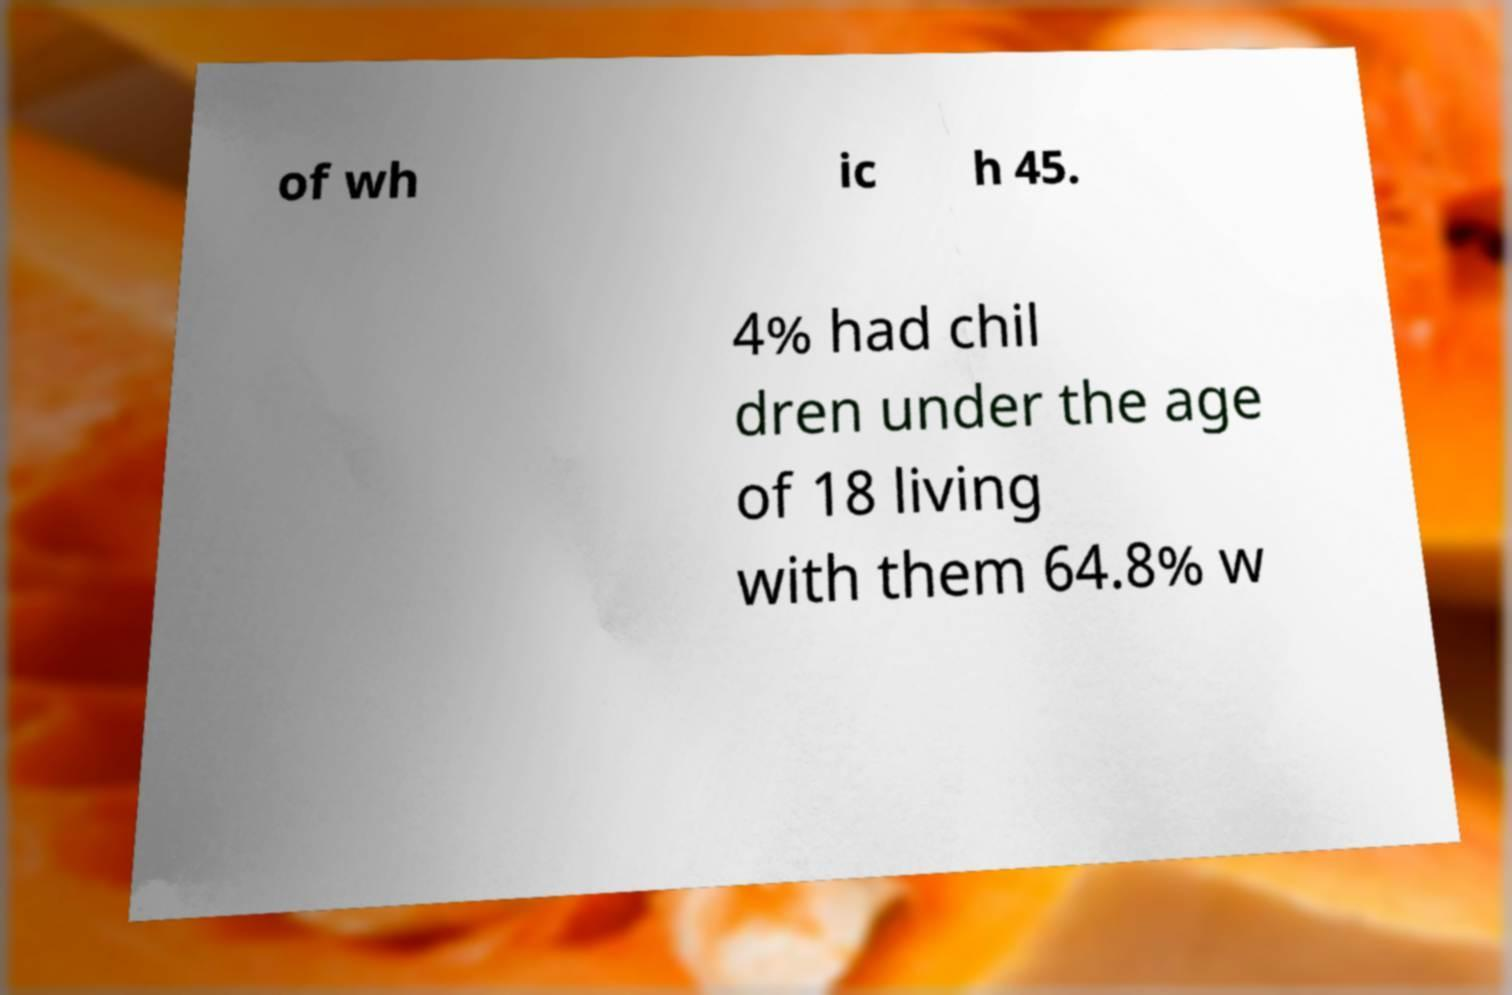Can you accurately transcribe the text from the provided image for me? of wh ic h 45. 4% had chil dren under the age of 18 living with them 64.8% w 